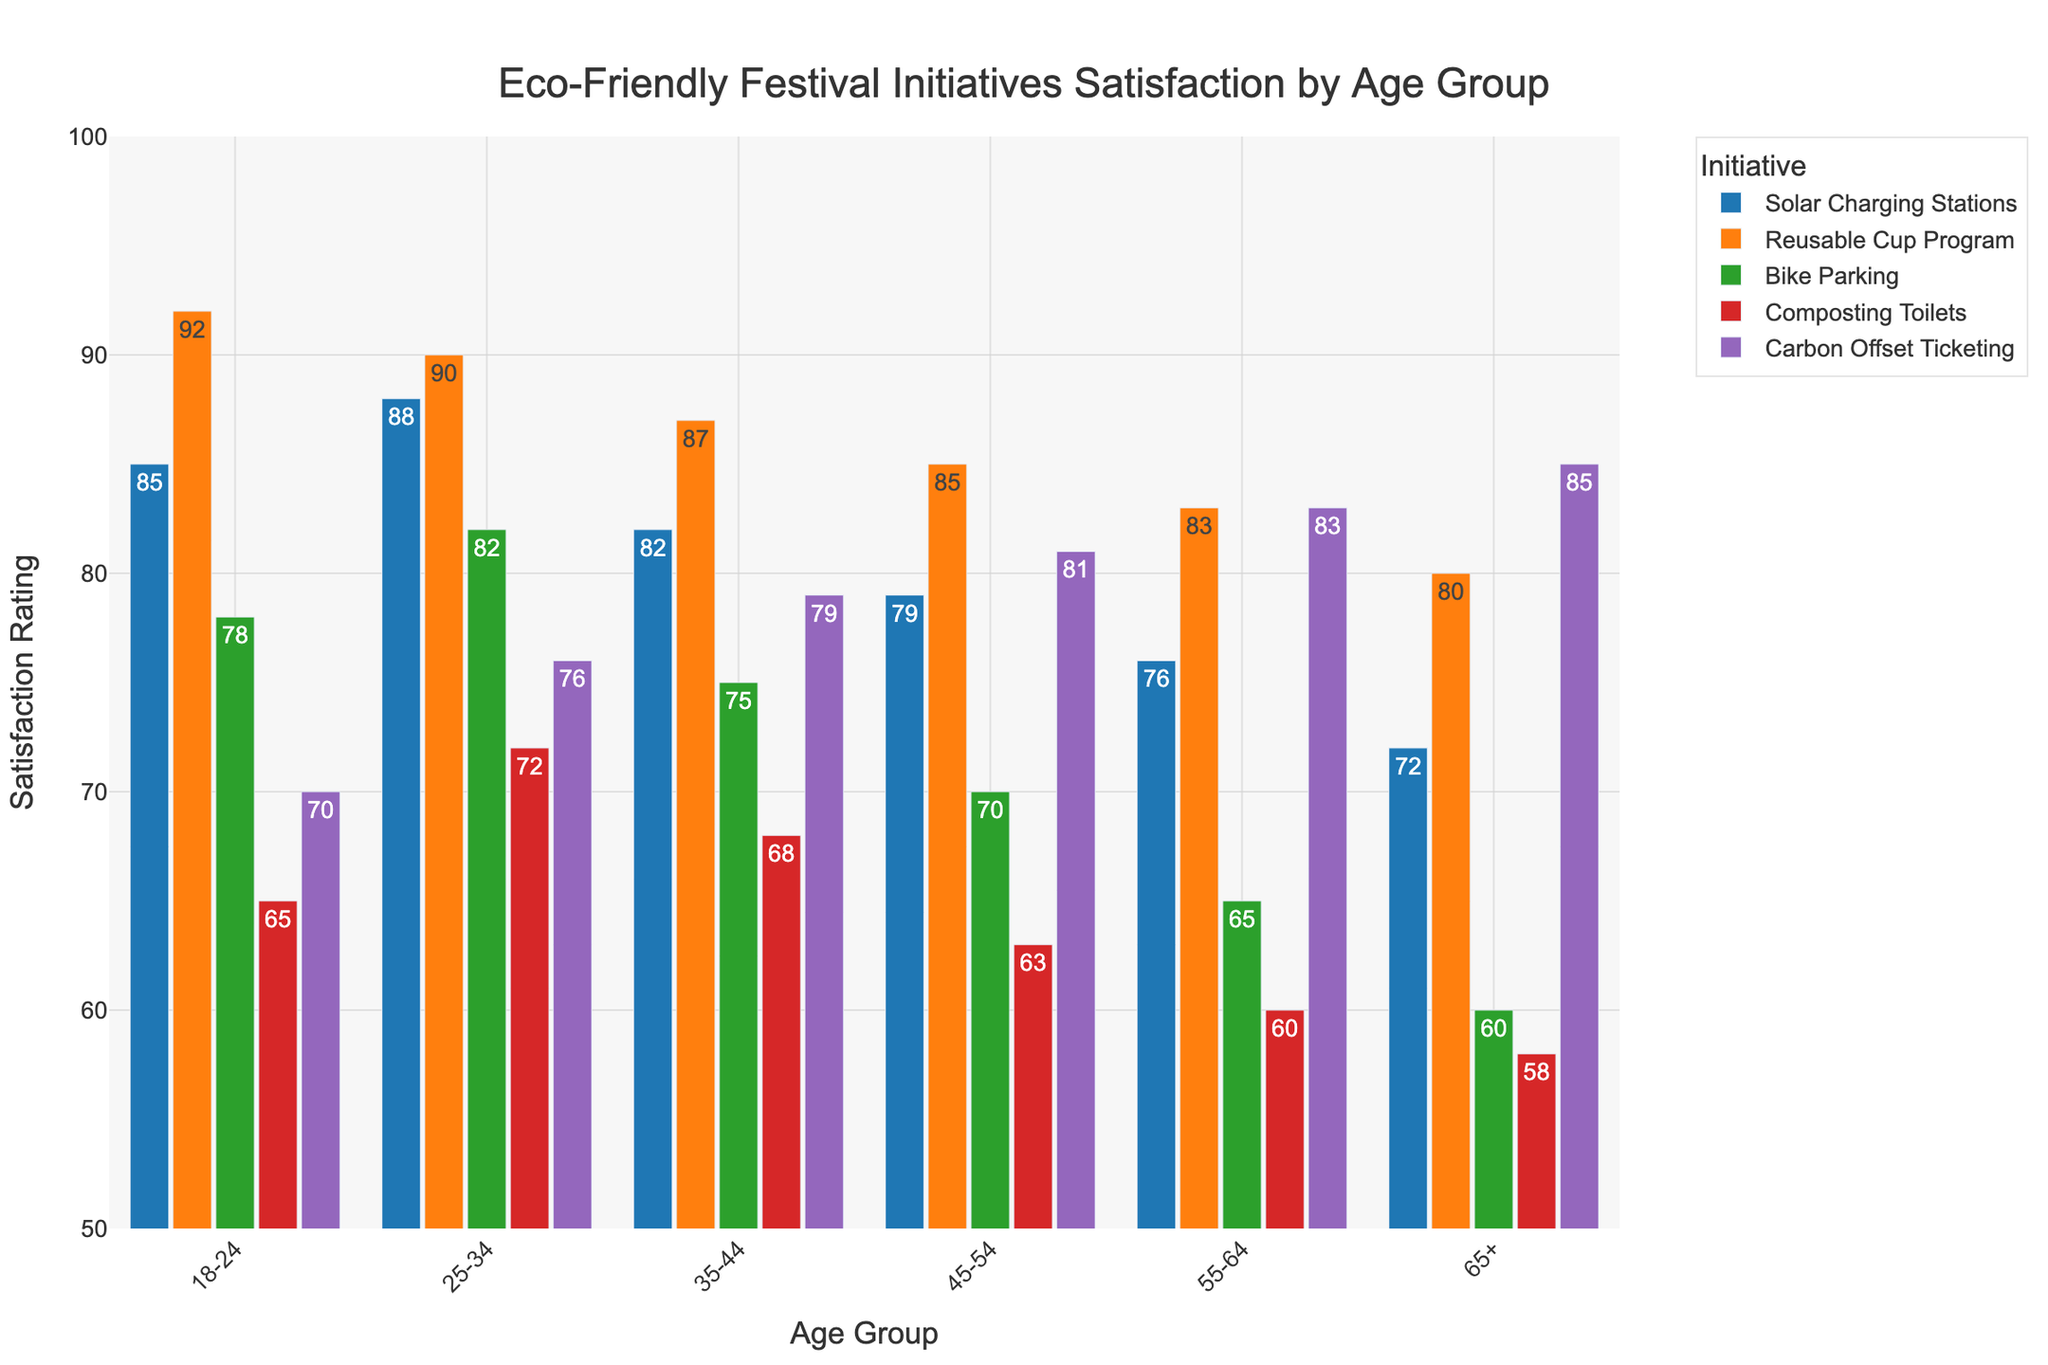Which age group shows the highest satisfaction for the Reusable Cup Program? The Reusable Cup Program bar for the 18-24 age group is the highest, indicating that this age group has the highest satisfaction for this initiative.
Answer: 18-24 Which eco-friendly initiative is least favored by the 65+ age group? The 65+ age group's least favored initiative is Composting Toilets, as it has the shortest bar compared to other initiatives for this age group.
Answer: Composting Toilets How does satisfaction with Solar Charging Stations compare between the 18-24 and 55-64 age groups? The satisfaction rating for Solar Charging Stations in the 18-24 age group is 85, while in the 55-64 age group, it is 76. Therefore, the 18-24 age group rates this initiative higher than the 55-64 age group.
Answer: 18-24 What is the difference in satisfaction ratings for Carbon Offset Ticketing between the 35-44 and 45-54 age groups? The satisfaction rating for Carbon Offset Ticketing is 79 for the 35-44 age group and 81 for the 45-54 age group. The difference is 81 - 79 = 2.
Answer: 2 Do attendees aged 35-44 generally prefer Carbon Offset Ticketing over Composting Toilets? For the 35-44 age group, the satisfaction rating for Carbon Offset Ticketing is 79, and for Composting Toilets, it is 68. Therefore, they prefer Carbon Offset Ticketing over Composting Toilets.
Answer: Yes 